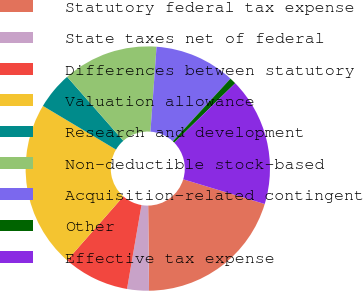<chart> <loc_0><loc_0><loc_500><loc_500><pie_chart><fcel>Statutory federal tax expense<fcel>State taxes net of federal<fcel>Differences between statutory<fcel>Valuation allowance<fcel>Research and development<fcel>Non-deductible stock-based<fcel>Acquisition-related contingent<fcel>Other<fcel>Effective tax expense<nl><fcel>20.16%<fcel>2.88%<fcel>8.76%<fcel>22.09%<fcel>4.95%<fcel>12.62%<fcel>10.69%<fcel>0.86%<fcel>16.99%<nl></chart> 